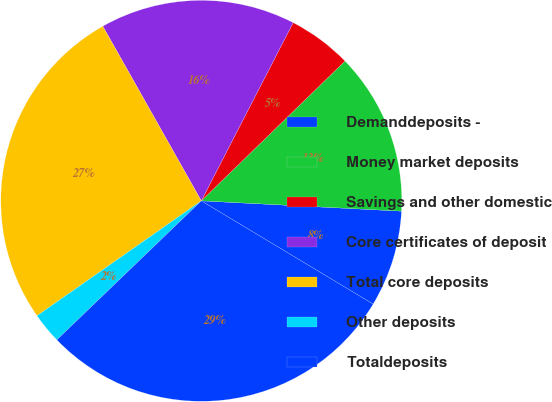<chart> <loc_0><loc_0><loc_500><loc_500><pie_chart><fcel>Demanddeposits -<fcel>Money market deposits<fcel>Savings and other domestic<fcel>Core certificates of deposit<fcel>Total core deposits<fcel>Other deposits<fcel>Totaldeposits<nl><fcel>7.79%<fcel>13.1%<fcel>5.14%<fcel>15.75%<fcel>26.54%<fcel>2.48%<fcel>29.19%<nl></chart> 